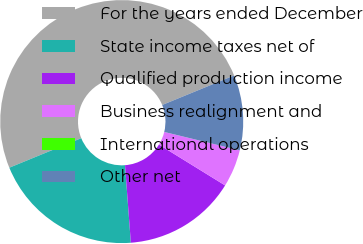<chart> <loc_0><loc_0><loc_500><loc_500><pie_chart><fcel>For the years ended December<fcel>State income taxes net of<fcel>Qualified production income<fcel>Business realignment and<fcel>International operations<fcel>Other net<nl><fcel>50.0%<fcel>20.0%<fcel>15.0%<fcel>5.0%<fcel>0.0%<fcel>10.0%<nl></chart> 